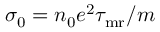<formula> <loc_0><loc_0><loc_500><loc_500>\sigma _ { 0 } = n _ { 0 } e ^ { 2 } \tau _ { m r } / m</formula> 